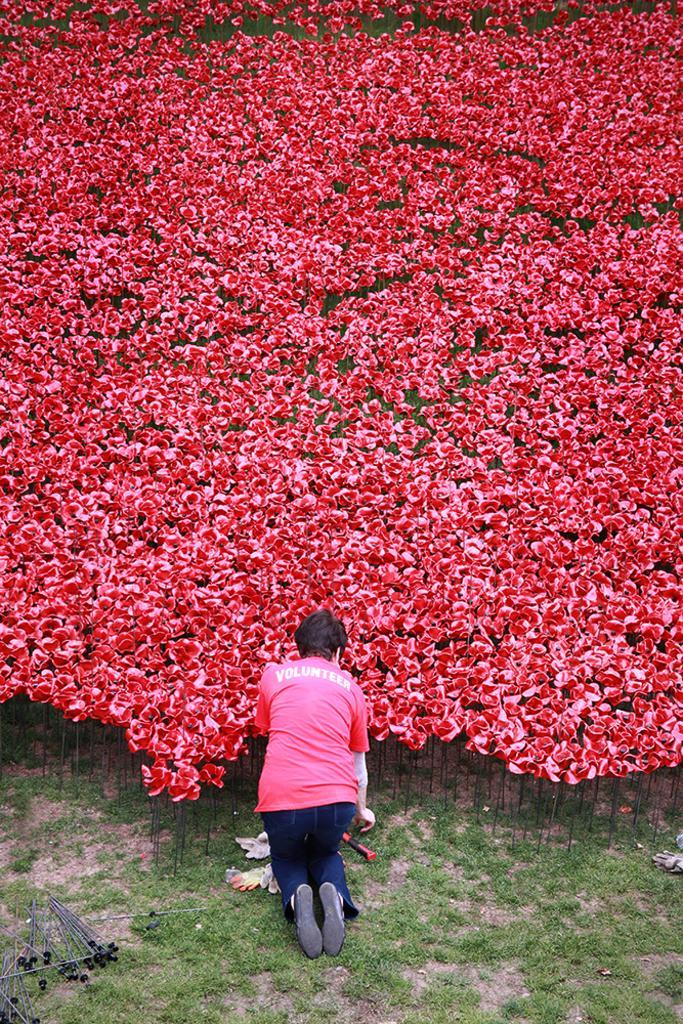Can you describe this image briefly? In the foreground of this image, there are few rod like structures on the ground and a person kneeling down and we can also see few flowers. 